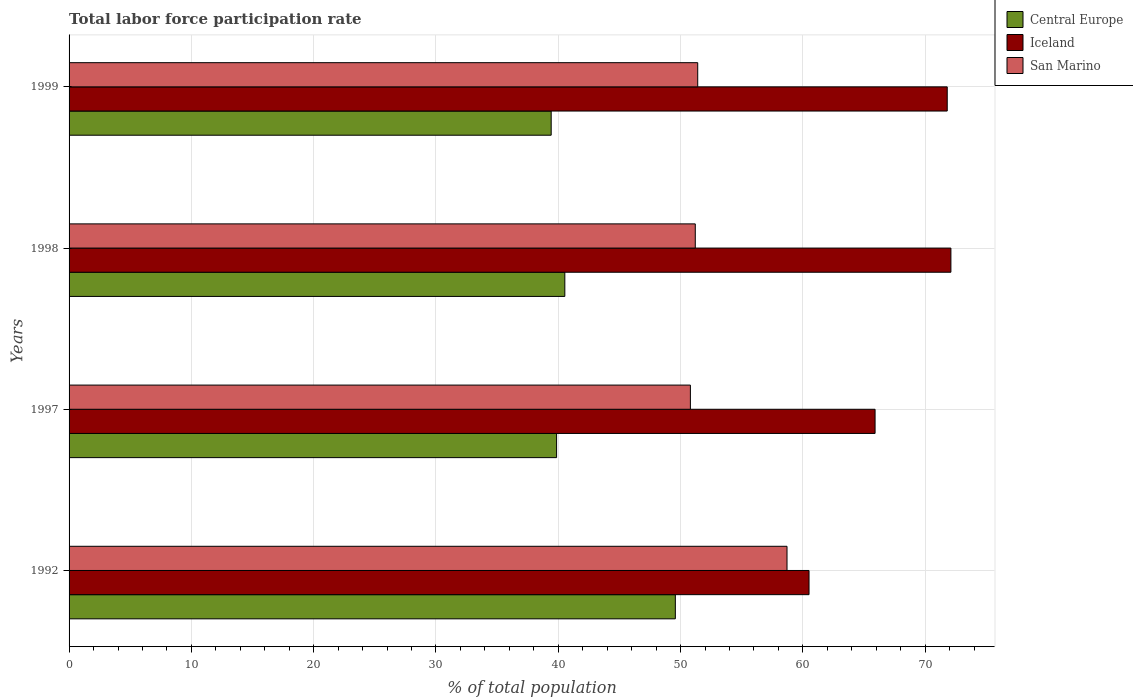How many different coloured bars are there?
Make the answer very short. 3. Are the number of bars per tick equal to the number of legend labels?
Ensure brevity in your answer.  Yes. Are the number of bars on each tick of the Y-axis equal?
Give a very brief answer. Yes. How many bars are there on the 2nd tick from the top?
Keep it short and to the point. 3. How many bars are there on the 3rd tick from the bottom?
Provide a succinct answer. 3. What is the label of the 2nd group of bars from the top?
Give a very brief answer. 1998. What is the total labor force participation rate in Central Europe in 1997?
Your answer should be compact. 39.86. Across all years, what is the maximum total labor force participation rate in San Marino?
Your response must be concise. 58.7. Across all years, what is the minimum total labor force participation rate in Central Europe?
Your answer should be compact. 39.42. In which year was the total labor force participation rate in San Marino maximum?
Provide a short and direct response. 1992. What is the total total labor force participation rate in Iceland in the graph?
Make the answer very short. 270.3. What is the difference between the total labor force participation rate in Iceland in 1992 and that in 1997?
Keep it short and to the point. -5.4. What is the difference between the total labor force participation rate in San Marino in 1992 and the total labor force participation rate in Central Europe in 1997?
Keep it short and to the point. 18.84. What is the average total labor force participation rate in San Marino per year?
Ensure brevity in your answer.  53.03. In the year 1998, what is the difference between the total labor force participation rate in Central Europe and total labor force participation rate in San Marino?
Make the answer very short. -10.67. What is the ratio of the total labor force participation rate in Iceland in 1998 to that in 1999?
Provide a short and direct response. 1. What is the difference between the highest and the second highest total labor force participation rate in San Marino?
Offer a very short reply. 7.3. What is the difference between the highest and the lowest total labor force participation rate in Iceland?
Make the answer very short. 11.6. What does the 2nd bar from the top in 1997 represents?
Make the answer very short. Iceland. What does the 3rd bar from the bottom in 1999 represents?
Offer a terse response. San Marino. Is it the case that in every year, the sum of the total labor force participation rate in Iceland and total labor force participation rate in Central Europe is greater than the total labor force participation rate in San Marino?
Your response must be concise. Yes. Are all the bars in the graph horizontal?
Your answer should be compact. Yes. How many years are there in the graph?
Your response must be concise. 4. What is the difference between two consecutive major ticks on the X-axis?
Your response must be concise. 10. Does the graph contain grids?
Your response must be concise. Yes. How many legend labels are there?
Offer a terse response. 3. How are the legend labels stacked?
Provide a short and direct response. Vertical. What is the title of the graph?
Provide a short and direct response. Total labor force participation rate. What is the label or title of the X-axis?
Provide a succinct answer. % of total population. What is the % of total population in Central Europe in 1992?
Keep it short and to the point. 49.57. What is the % of total population of Iceland in 1992?
Offer a very short reply. 60.5. What is the % of total population in San Marino in 1992?
Offer a terse response. 58.7. What is the % of total population of Central Europe in 1997?
Your answer should be very brief. 39.86. What is the % of total population of Iceland in 1997?
Keep it short and to the point. 65.9. What is the % of total population of San Marino in 1997?
Your answer should be very brief. 50.8. What is the % of total population in Central Europe in 1998?
Your response must be concise. 40.53. What is the % of total population of Iceland in 1998?
Your answer should be very brief. 72.1. What is the % of total population in San Marino in 1998?
Provide a short and direct response. 51.2. What is the % of total population of Central Europe in 1999?
Provide a short and direct response. 39.42. What is the % of total population in Iceland in 1999?
Your response must be concise. 71.8. What is the % of total population in San Marino in 1999?
Your response must be concise. 51.4. Across all years, what is the maximum % of total population of Central Europe?
Offer a terse response. 49.57. Across all years, what is the maximum % of total population of Iceland?
Provide a short and direct response. 72.1. Across all years, what is the maximum % of total population of San Marino?
Offer a very short reply. 58.7. Across all years, what is the minimum % of total population of Central Europe?
Provide a succinct answer. 39.42. Across all years, what is the minimum % of total population of Iceland?
Keep it short and to the point. 60.5. Across all years, what is the minimum % of total population of San Marino?
Ensure brevity in your answer.  50.8. What is the total % of total population of Central Europe in the graph?
Offer a very short reply. 169.38. What is the total % of total population of Iceland in the graph?
Offer a very short reply. 270.3. What is the total % of total population of San Marino in the graph?
Give a very brief answer. 212.1. What is the difference between the % of total population in Central Europe in 1992 and that in 1997?
Give a very brief answer. 9.71. What is the difference between the % of total population of San Marino in 1992 and that in 1997?
Offer a terse response. 7.9. What is the difference between the % of total population in Central Europe in 1992 and that in 1998?
Make the answer very short. 9.03. What is the difference between the % of total population in Iceland in 1992 and that in 1998?
Offer a very short reply. -11.6. What is the difference between the % of total population in San Marino in 1992 and that in 1998?
Offer a very short reply. 7.5. What is the difference between the % of total population of Central Europe in 1992 and that in 1999?
Make the answer very short. 10.15. What is the difference between the % of total population in Central Europe in 1997 and that in 1998?
Your answer should be very brief. -0.67. What is the difference between the % of total population of Iceland in 1997 and that in 1998?
Keep it short and to the point. -6.2. What is the difference between the % of total population in San Marino in 1997 and that in 1998?
Provide a succinct answer. -0.4. What is the difference between the % of total population of Central Europe in 1997 and that in 1999?
Provide a short and direct response. 0.44. What is the difference between the % of total population in San Marino in 1997 and that in 1999?
Provide a short and direct response. -0.6. What is the difference between the % of total population of Central Europe in 1998 and that in 1999?
Offer a very short reply. 1.12. What is the difference between the % of total population of Central Europe in 1992 and the % of total population of Iceland in 1997?
Keep it short and to the point. -16.33. What is the difference between the % of total population in Central Europe in 1992 and the % of total population in San Marino in 1997?
Give a very brief answer. -1.23. What is the difference between the % of total population in Central Europe in 1992 and the % of total population in Iceland in 1998?
Offer a very short reply. -22.53. What is the difference between the % of total population of Central Europe in 1992 and the % of total population of San Marino in 1998?
Make the answer very short. -1.63. What is the difference between the % of total population of Iceland in 1992 and the % of total population of San Marino in 1998?
Make the answer very short. 9.3. What is the difference between the % of total population in Central Europe in 1992 and the % of total population in Iceland in 1999?
Offer a very short reply. -22.23. What is the difference between the % of total population of Central Europe in 1992 and the % of total population of San Marino in 1999?
Provide a succinct answer. -1.83. What is the difference between the % of total population of Iceland in 1992 and the % of total population of San Marino in 1999?
Your response must be concise. 9.1. What is the difference between the % of total population in Central Europe in 1997 and the % of total population in Iceland in 1998?
Make the answer very short. -32.24. What is the difference between the % of total population of Central Europe in 1997 and the % of total population of San Marino in 1998?
Your answer should be very brief. -11.34. What is the difference between the % of total population in Central Europe in 1997 and the % of total population in Iceland in 1999?
Ensure brevity in your answer.  -31.94. What is the difference between the % of total population in Central Europe in 1997 and the % of total population in San Marino in 1999?
Offer a very short reply. -11.54. What is the difference between the % of total population in Central Europe in 1998 and the % of total population in Iceland in 1999?
Offer a very short reply. -31.27. What is the difference between the % of total population in Central Europe in 1998 and the % of total population in San Marino in 1999?
Make the answer very short. -10.87. What is the difference between the % of total population of Iceland in 1998 and the % of total population of San Marino in 1999?
Ensure brevity in your answer.  20.7. What is the average % of total population in Central Europe per year?
Give a very brief answer. 42.35. What is the average % of total population in Iceland per year?
Make the answer very short. 67.58. What is the average % of total population of San Marino per year?
Ensure brevity in your answer.  53.02. In the year 1992, what is the difference between the % of total population in Central Europe and % of total population in Iceland?
Give a very brief answer. -10.93. In the year 1992, what is the difference between the % of total population of Central Europe and % of total population of San Marino?
Provide a short and direct response. -9.13. In the year 1997, what is the difference between the % of total population in Central Europe and % of total population in Iceland?
Give a very brief answer. -26.04. In the year 1997, what is the difference between the % of total population of Central Europe and % of total population of San Marino?
Provide a short and direct response. -10.94. In the year 1997, what is the difference between the % of total population of Iceland and % of total population of San Marino?
Your response must be concise. 15.1. In the year 1998, what is the difference between the % of total population in Central Europe and % of total population in Iceland?
Give a very brief answer. -31.57. In the year 1998, what is the difference between the % of total population in Central Europe and % of total population in San Marino?
Your answer should be compact. -10.67. In the year 1998, what is the difference between the % of total population of Iceland and % of total population of San Marino?
Your answer should be very brief. 20.9. In the year 1999, what is the difference between the % of total population of Central Europe and % of total population of Iceland?
Provide a short and direct response. -32.38. In the year 1999, what is the difference between the % of total population in Central Europe and % of total population in San Marino?
Offer a very short reply. -11.98. In the year 1999, what is the difference between the % of total population in Iceland and % of total population in San Marino?
Offer a terse response. 20.4. What is the ratio of the % of total population of Central Europe in 1992 to that in 1997?
Offer a very short reply. 1.24. What is the ratio of the % of total population of Iceland in 1992 to that in 1997?
Offer a very short reply. 0.92. What is the ratio of the % of total population in San Marino in 1992 to that in 1997?
Offer a terse response. 1.16. What is the ratio of the % of total population of Central Europe in 1992 to that in 1998?
Your answer should be compact. 1.22. What is the ratio of the % of total population in Iceland in 1992 to that in 1998?
Ensure brevity in your answer.  0.84. What is the ratio of the % of total population in San Marino in 1992 to that in 1998?
Your response must be concise. 1.15. What is the ratio of the % of total population of Central Europe in 1992 to that in 1999?
Provide a succinct answer. 1.26. What is the ratio of the % of total population in Iceland in 1992 to that in 1999?
Give a very brief answer. 0.84. What is the ratio of the % of total population of San Marino in 1992 to that in 1999?
Make the answer very short. 1.14. What is the ratio of the % of total population in Central Europe in 1997 to that in 1998?
Give a very brief answer. 0.98. What is the ratio of the % of total population of Iceland in 1997 to that in 1998?
Offer a very short reply. 0.91. What is the ratio of the % of total population in San Marino in 1997 to that in 1998?
Provide a short and direct response. 0.99. What is the ratio of the % of total population of Central Europe in 1997 to that in 1999?
Make the answer very short. 1.01. What is the ratio of the % of total population of Iceland in 1997 to that in 1999?
Make the answer very short. 0.92. What is the ratio of the % of total population of San Marino in 1997 to that in 1999?
Provide a succinct answer. 0.99. What is the ratio of the % of total population of Central Europe in 1998 to that in 1999?
Make the answer very short. 1.03. What is the ratio of the % of total population of Iceland in 1998 to that in 1999?
Make the answer very short. 1. What is the difference between the highest and the second highest % of total population of Central Europe?
Keep it short and to the point. 9.03. What is the difference between the highest and the lowest % of total population in Central Europe?
Your answer should be compact. 10.15. What is the difference between the highest and the lowest % of total population of Iceland?
Give a very brief answer. 11.6. 